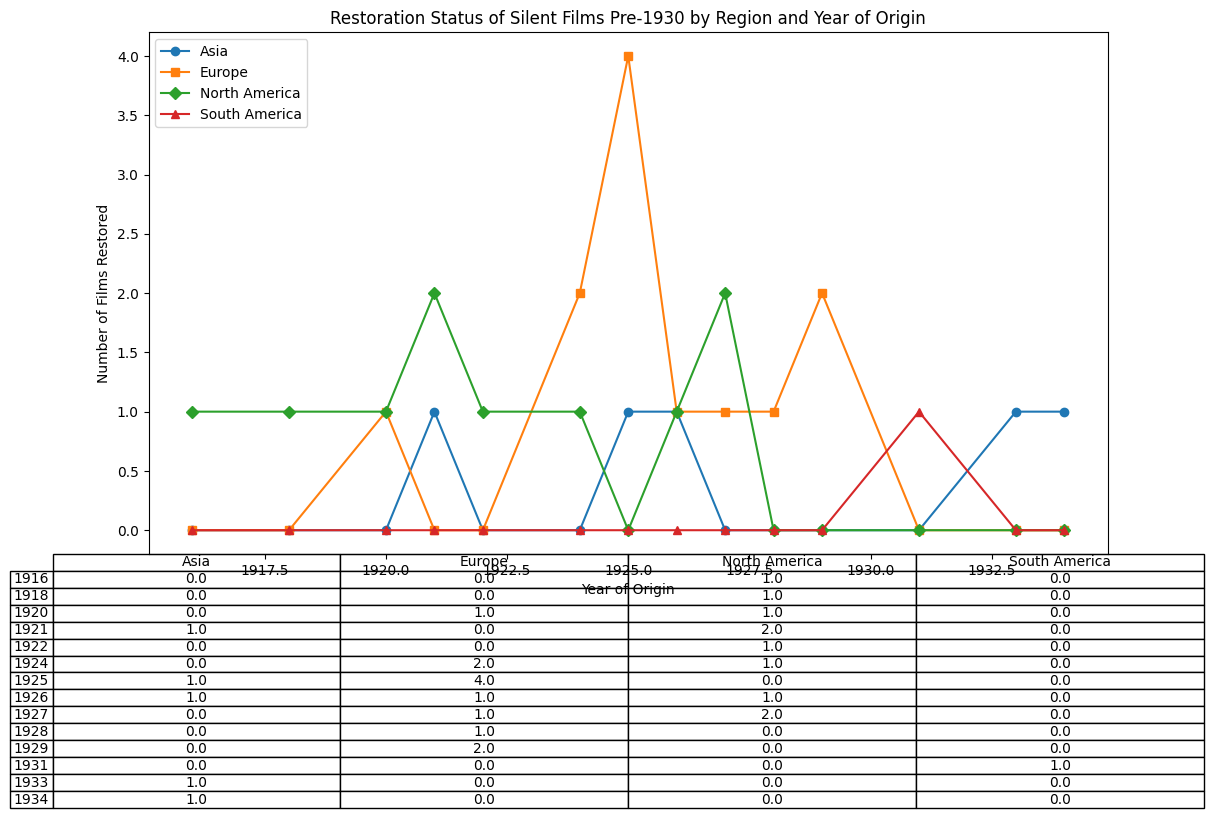How many films from North America were restored in 2018? From the plot, locate North America and trace it to 2018. The table shows 'Germany's Last Stand' and 'The Sheik', so two films were restored.
Answer: 2 Which region had the most films from 1925 restored? Look at the year 1925 on the plot and observe the different regions. Specifically, the table shows Europe (4 films: Strike, Battleship Potemkin, Variety, and Faust), Asia (1 film: Dragnet Girl). Hence, Europe has the most.
Answer: Europe Is there a difference in number of films restored between 1920 and 1921 for Europe? On examining the plot's markers for Europe in 1920 and 1921, there's one film 'The Cabinet of Dr. Caligari' for 1920 and zero for 1921. The difference is one film.
Answer: 1 How does the restoration trend for Asia compare to Europe from 1920 to 1930? Assess the plot markers for both regions over the years. For Asia, restorations in 1925, 1933, 1926, 1934; for Europe, restorations occur almost each year significantly higher and consistently. Thus, Europe maintained a higher, more consistent restore trend than Asia.
Answer: Europe has a more consistent and higher trend What's the visual distribution of restored films for North America across the years? Observe the pattern of markers (o) for North America. Films appear consistently dotted across the years, particularly clustered around early to mid-1920s.
Answer: Consistent and clustered in early to mid-1920s How many films in total were restored from America and Europe before 1925? Summing from the table: North America (7 films: The Kid, Nosferatu, Germany's Last Stand, The Sheik, The General, Sunrise: A Song of Two Humans, Intolerance), Europe (9 films: The Cabinet of Dr. Caligari, Metropolis, The Passion of Joan of Arc, Pandora's Box, The Man with the Movie Camera, Strike, Faust, Variety, Waxworks). Hence, North America = 4; Europe = 4
Answer: 8 What is the combined number of films restored from all regions post-1930? Scan the table for restoration years beyond 1930 for each region. Only South America appears with 'Limite' being restored in 2006 and 'Dragnet Girl' in 2013. Sum = 2 from South America and Asia.
Answer: 2 Which film from Europe restored the latest? Find the latest year marker for Europe from the table and the plot which is 2021 for 'Nosferatu'
Answer: Nosferatu Compare the number of restored films between North America and Asia in 1934 and provide the difference. Observe the table entries: North America has 0; Asia has 'The Goddess'. Hence, the difference is 0 - 1 = -1.
Answer: -1 